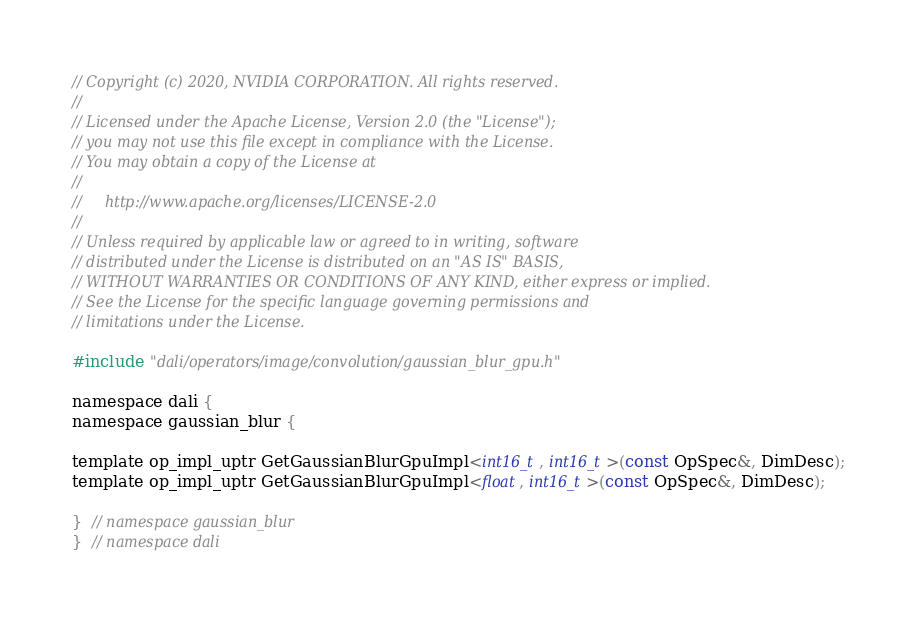Convert code to text. <code><loc_0><loc_0><loc_500><loc_500><_Cuda_>// Copyright (c) 2020, NVIDIA CORPORATION. All rights reserved.
//
// Licensed under the Apache License, Version 2.0 (the "License");
// you may not use this file except in compliance with the License.
// You may obtain a copy of the License at
//
//     http://www.apache.org/licenses/LICENSE-2.0
//
// Unless required by applicable law or agreed to in writing, software
// distributed under the License is distributed on an "AS IS" BASIS,
// WITHOUT WARRANTIES OR CONDITIONS OF ANY KIND, either express or implied.
// See the License for the specific language governing permissions and
// limitations under the License.

#include "dali/operators/image/convolution/gaussian_blur_gpu.h"

namespace dali {
namespace gaussian_blur {

template op_impl_uptr GetGaussianBlurGpuImpl<int16_t, int16_t>(const OpSpec&, DimDesc);
template op_impl_uptr GetGaussianBlurGpuImpl<float, int16_t>(const OpSpec&, DimDesc);

}  // namespace gaussian_blur
}  // namespace dali
</code> 